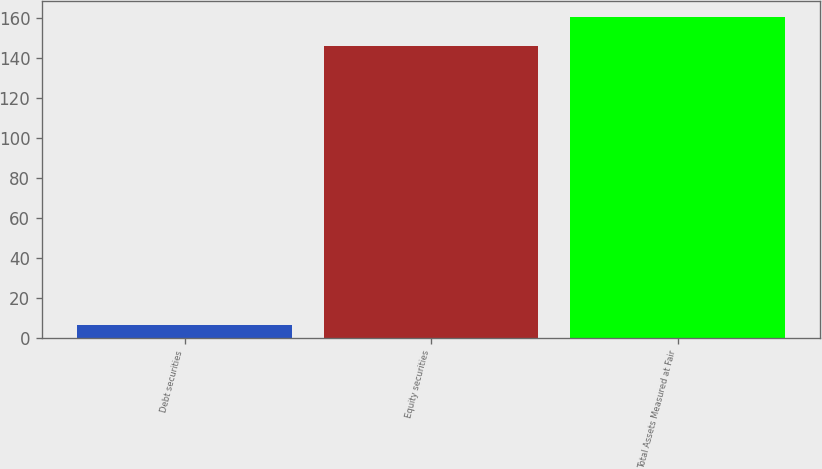<chart> <loc_0><loc_0><loc_500><loc_500><bar_chart><fcel>Debt securities<fcel>Equity securities<fcel>Total Assets Measured at Fair<nl><fcel>6.3<fcel>145.9<fcel>160.49<nl></chart> 